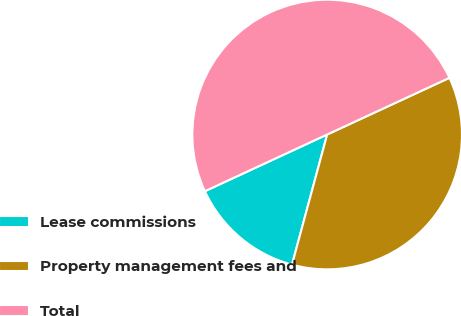<chart> <loc_0><loc_0><loc_500><loc_500><pie_chart><fcel>Lease commissions<fcel>Property management fees and<fcel>Total<nl><fcel>13.89%<fcel>36.11%<fcel>50.0%<nl></chart> 